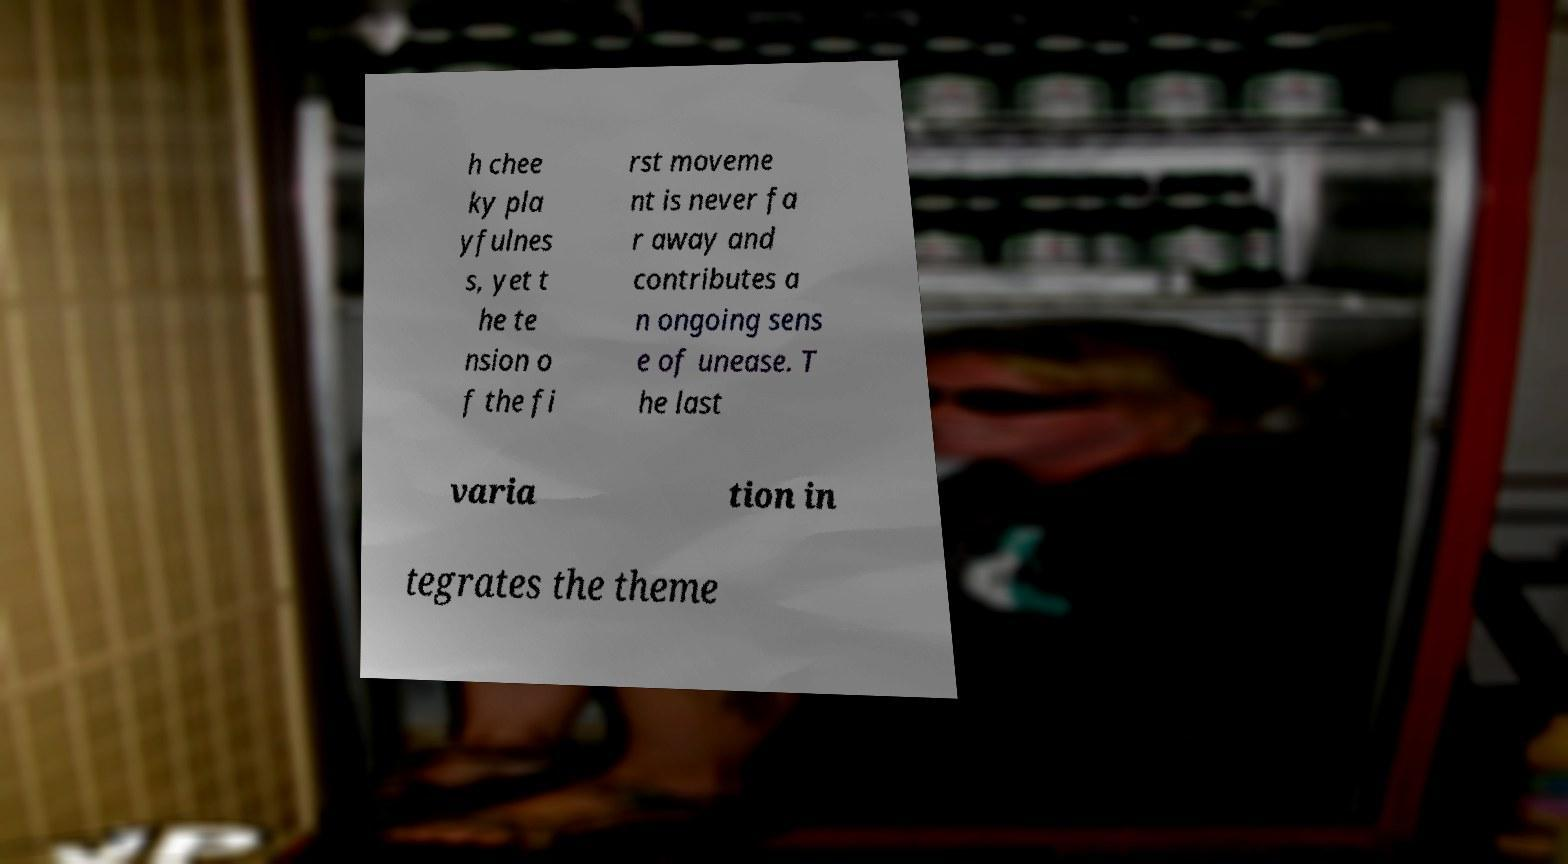Could you assist in decoding the text presented in this image and type it out clearly? h chee ky pla yfulnes s, yet t he te nsion o f the fi rst moveme nt is never fa r away and contributes a n ongoing sens e of unease. T he last varia tion in tegrates the theme 